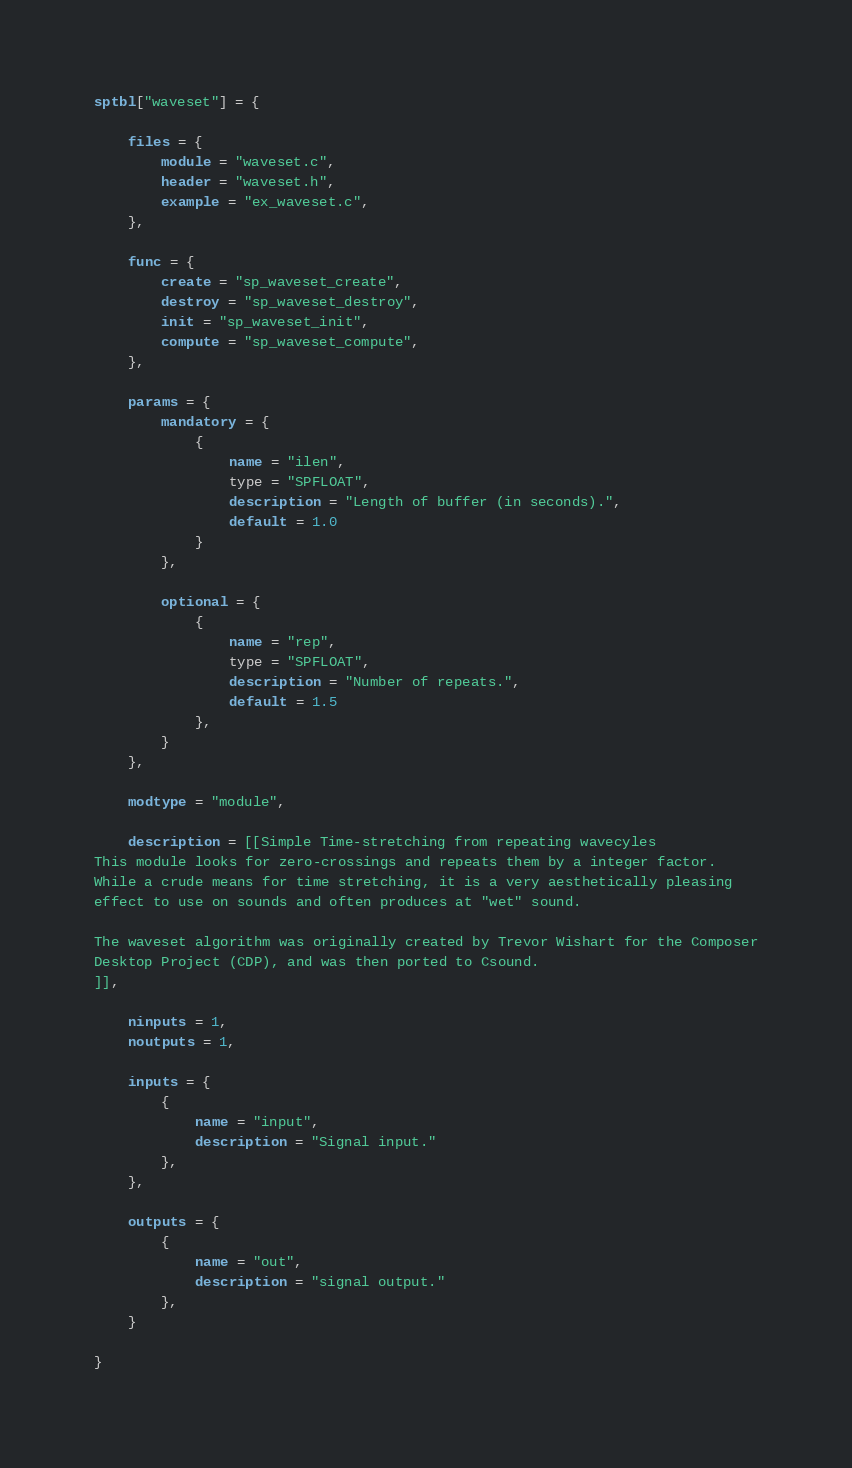Convert code to text. <code><loc_0><loc_0><loc_500><loc_500><_Lua_>sptbl["waveset"] = {

    files = {
        module = "waveset.c",
        header = "waveset.h",
        example = "ex_waveset.c",
    },

    func = {
        create = "sp_waveset_create",
        destroy = "sp_waveset_destroy",
        init = "sp_waveset_init",
        compute = "sp_waveset_compute",
    },

    params = {
        mandatory = {
            {
                name = "ilen",
                type = "SPFLOAT",
                description = "Length of buffer (in seconds).",
                default = 1.0 
            }
        },

        optional = {
            {
                name = "rep",
                type = "SPFLOAT",
                description = "Number of repeats.",
                default = 1.5
            },
        }
    },

    modtype = "module",

    description = [[Simple Time-stretching from repeating wavecyles
This module looks for zero-crossings and repeats them by a integer factor.
While a crude means for time stretching, it is a very aesthetically pleasing 
effect to use on sounds and often produces at "wet" sound.

The waveset algorithm was originally created by Trevor Wishart for the Composer
Desktop Project (CDP), and was then ported to Csound. 
]],

    ninputs = 1,
    noutputs = 1,

    inputs = {
        {
            name = "input",
            description = "Signal input."
        },
    },

    outputs = {
        {
            name = "out",
            description = "signal output."
        },
    }

}
</code> 